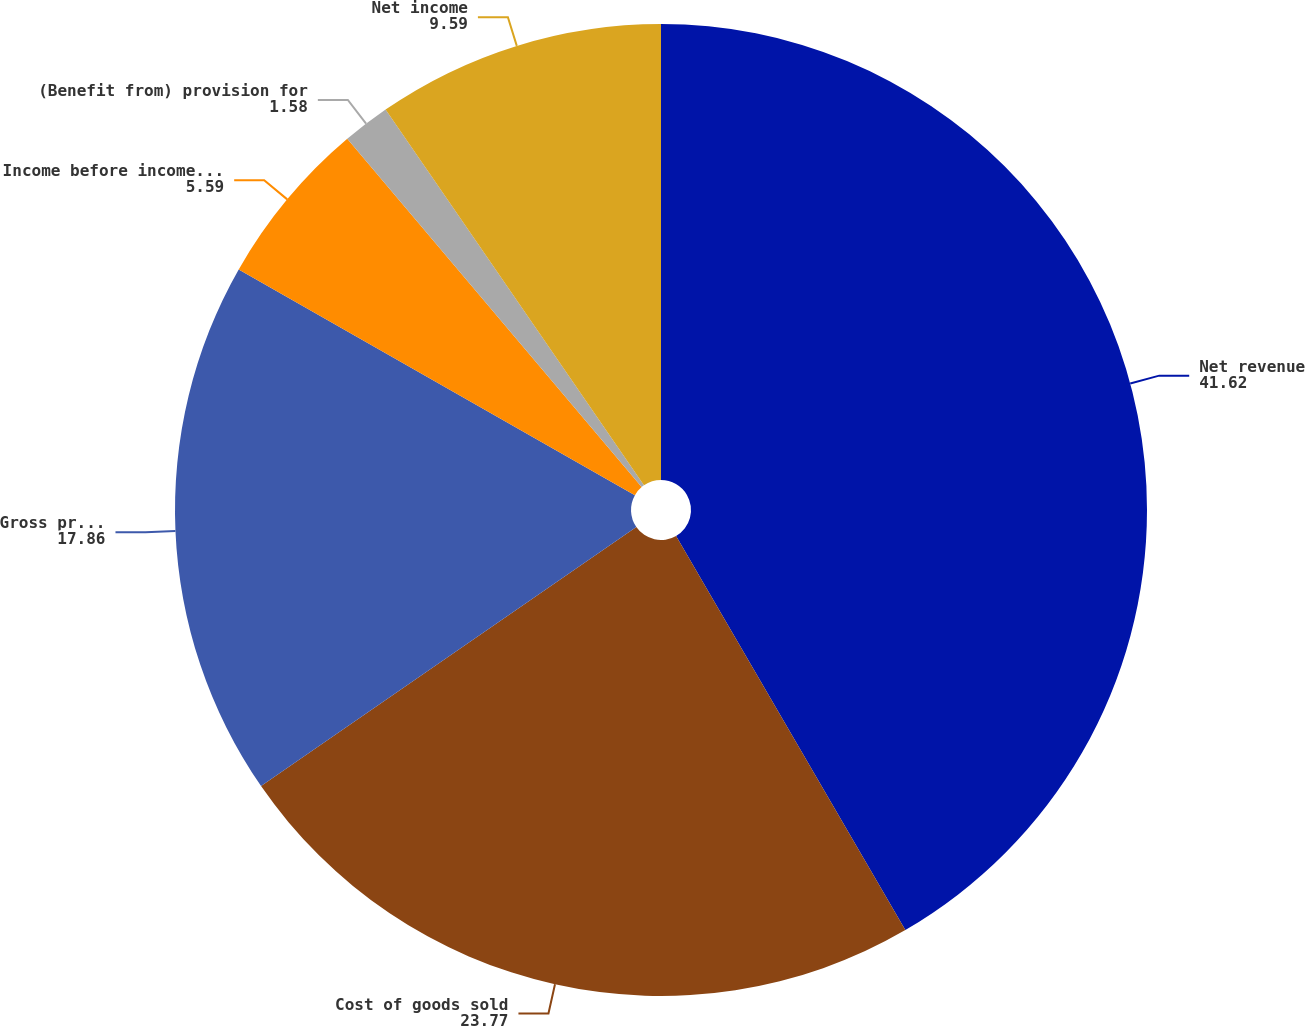Convert chart to OTSL. <chart><loc_0><loc_0><loc_500><loc_500><pie_chart><fcel>Net revenue<fcel>Cost of goods sold<fcel>Gross profit<fcel>Income before income taxes<fcel>(Benefit from) provision for<fcel>Net income<nl><fcel>41.62%<fcel>23.77%<fcel>17.86%<fcel>5.59%<fcel>1.58%<fcel>9.59%<nl></chart> 